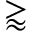Convert formula to latex. <formula><loc_0><loc_0><loc_500><loc_500>\gtrapprox</formula> 